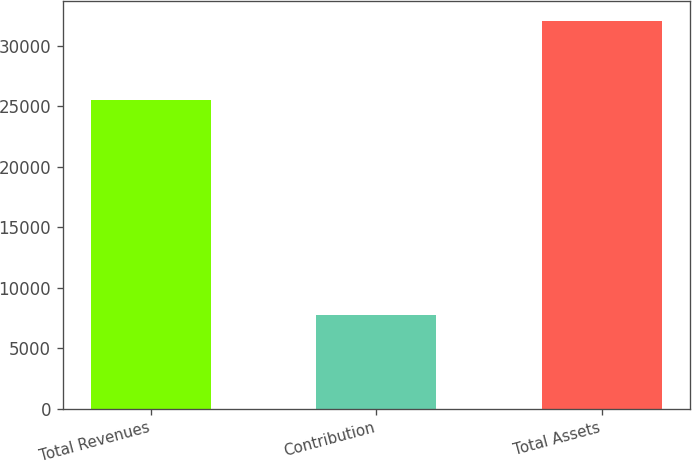<chart> <loc_0><loc_0><loc_500><loc_500><bar_chart><fcel>Total Revenues<fcel>Contribution<fcel>Total Assets<nl><fcel>25512<fcel>7712<fcel>32079<nl></chart> 